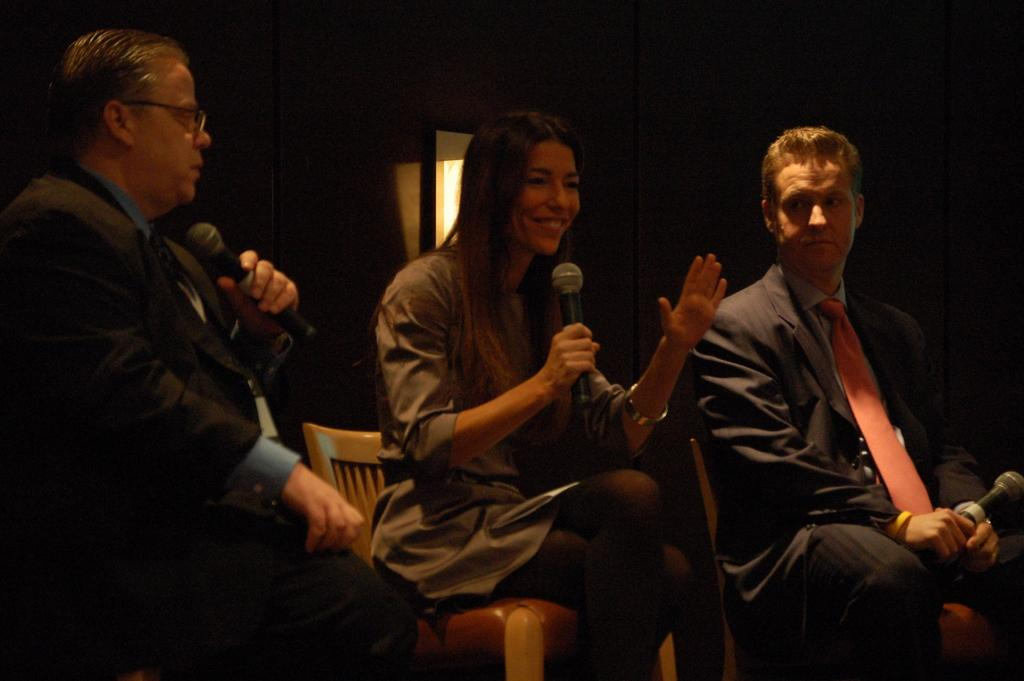How many people are in the image? There are three people in the image. What are the people doing in the image? The people are sitting on chairs and holding microphones. What can be observed about the people's clothing? The people are wearing different color dresses. What is the color of the background in the image? The background of the image is dark. What type of plants can be seen growing on the ornament in the image? There is no ornament or plants present in the image. Can you tell me how many horses are visible in the image? There are no horses present in the image. 